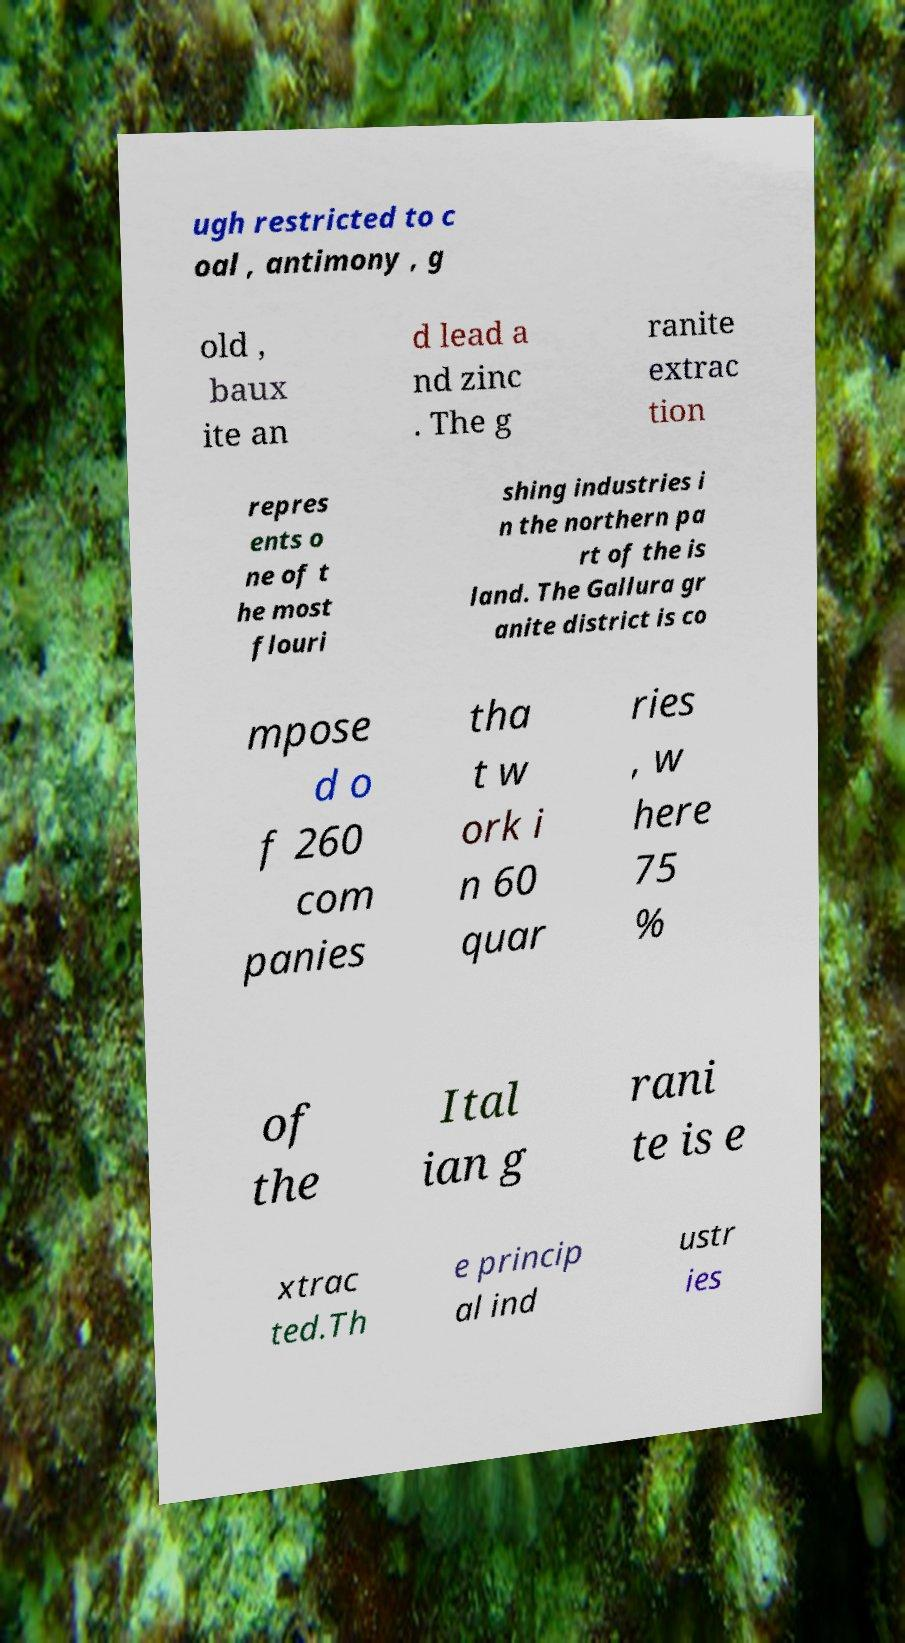I need the written content from this picture converted into text. Can you do that? ugh restricted to c oal , antimony , g old , baux ite an d lead a nd zinc . The g ranite extrac tion repres ents o ne of t he most flouri shing industries i n the northern pa rt of the is land. The Gallura gr anite district is co mpose d o f 260 com panies tha t w ork i n 60 quar ries , w here 75 % of the Ital ian g rani te is e xtrac ted.Th e princip al ind ustr ies 